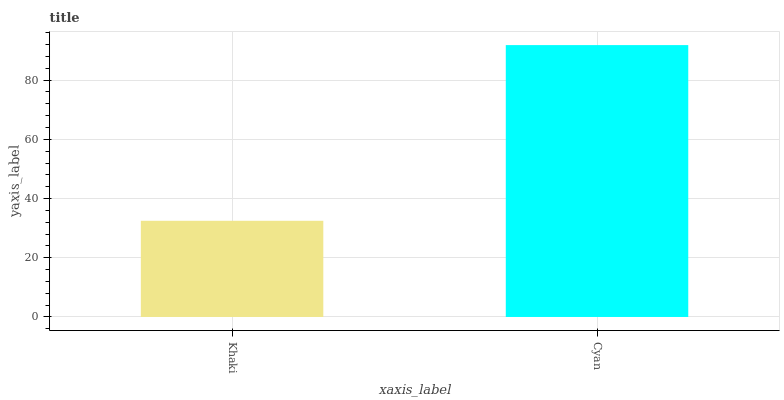Is Khaki the minimum?
Answer yes or no. Yes. Is Cyan the maximum?
Answer yes or no. Yes. Is Cyan the minimum?
Answer yes or no. No. Is Cyan greater than Khaki?
Answer yes or no. Yes. Is Khaki less than Cyan?
Answer yes or no. Yes. Is Khaki greater than Cyan?
Answer yes or no. No. Is Cyan less than Khaki?
Answer yes or no. No. Is Cyan the high median?
Answer yes or no. Yes. Is Khaki the low median?
Answer yes or no. Yes. Is Khaki the high median?
Answer yes or no. No. Is Cyan the low median?
Answer yes or no. No. 